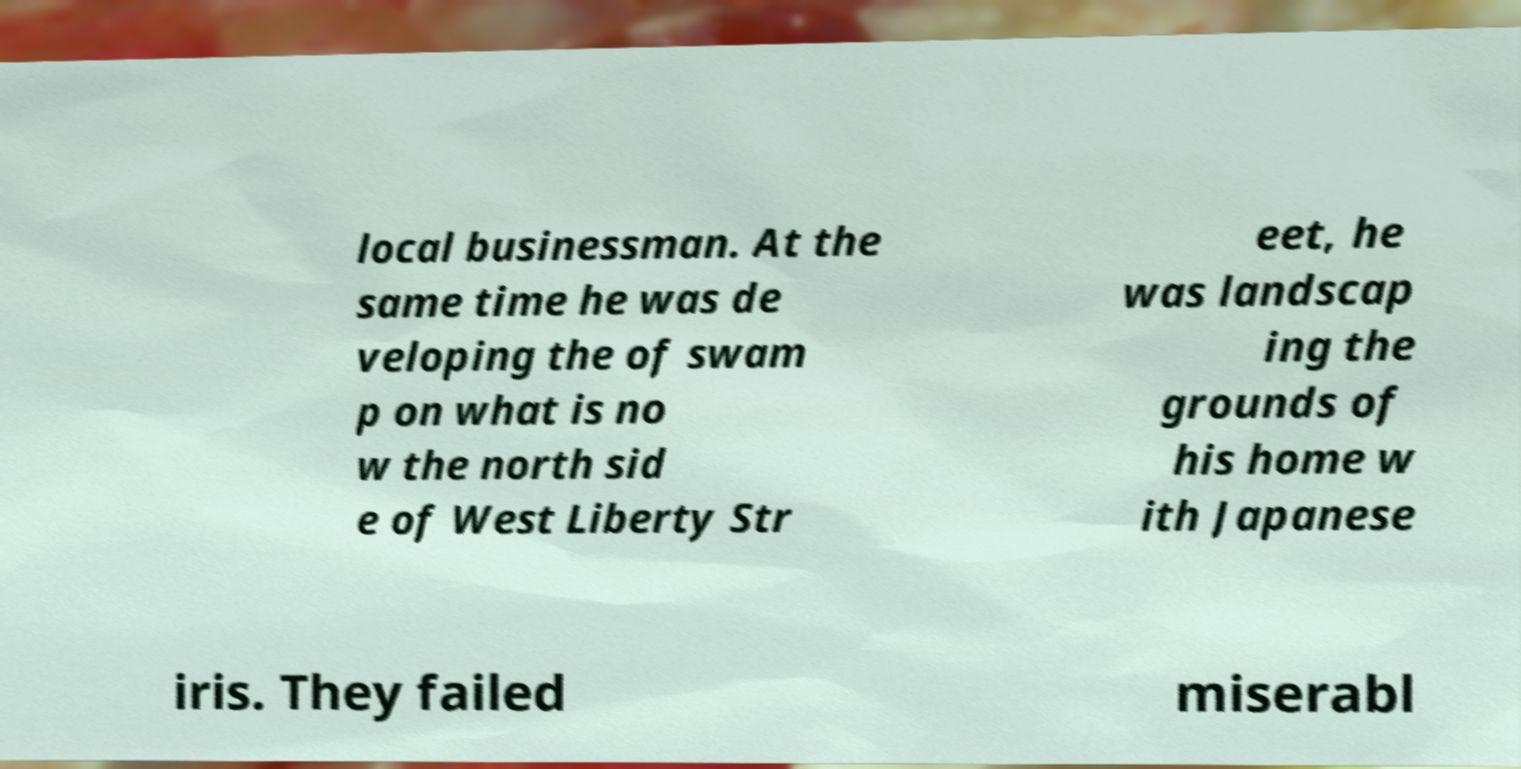Can you accurately transcribe the text from the provided image for me? local businessman. At the same time he was de veloping the of swam p on what is no w the north sid e of West Liberty Str eet, he was landscap ing the grounds of his home w ith Japanese iris. They failed miserabl 